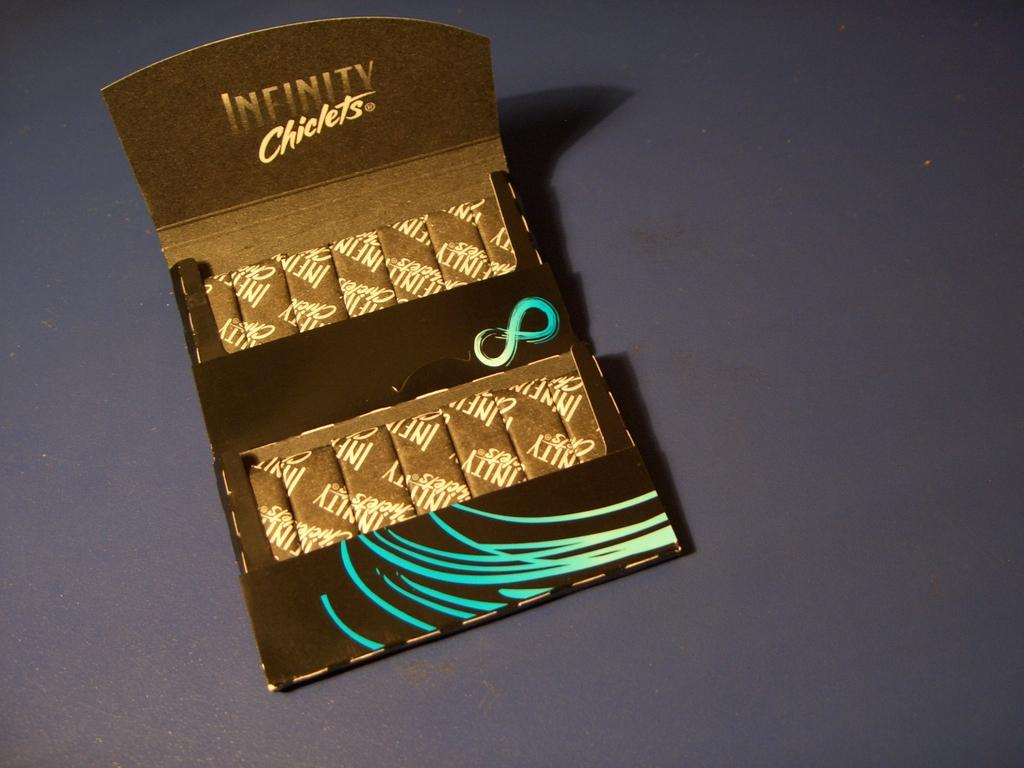<image>
Summarize the visual content of the image. A packet of Infinity Chiclets on a table. 